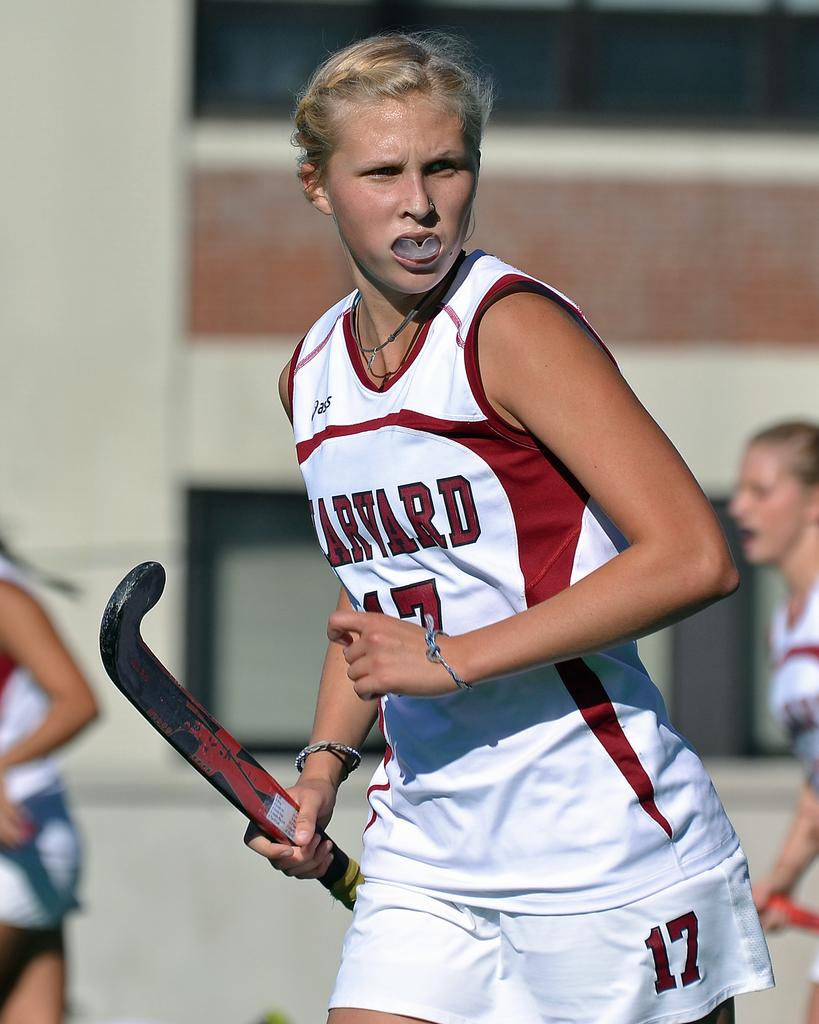<image>
Share a concise interpretation of the image provided. A Harvard hockey player is looking away from the ground 